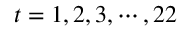<formula> <loc_0><loc_0><loc_500><loc_500>t = 1 , 2 , 3 , \cdots , 2 2</formula> 